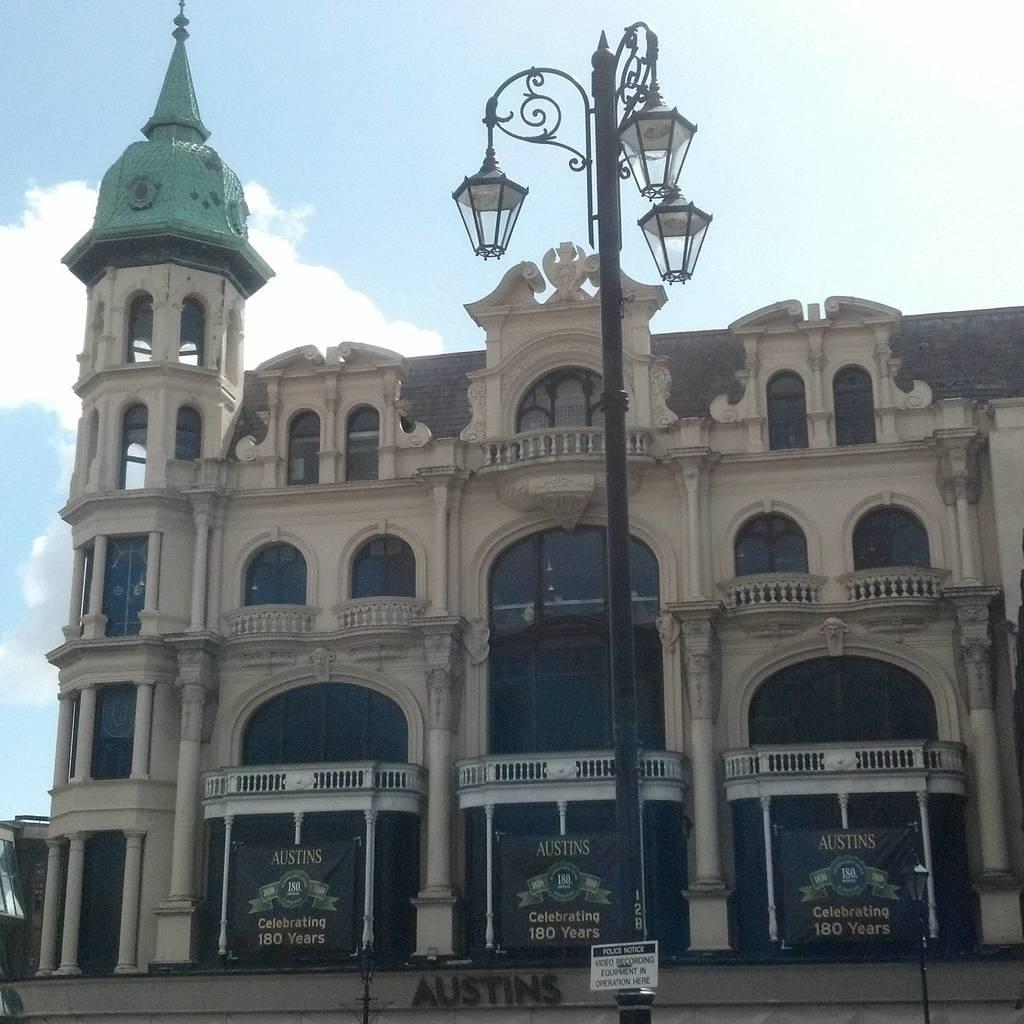How many years are they celebrating?
Ensure brevity in your answer.  180. What is the name at the bottom of the building?
Provide a succinct answer. Austins. 